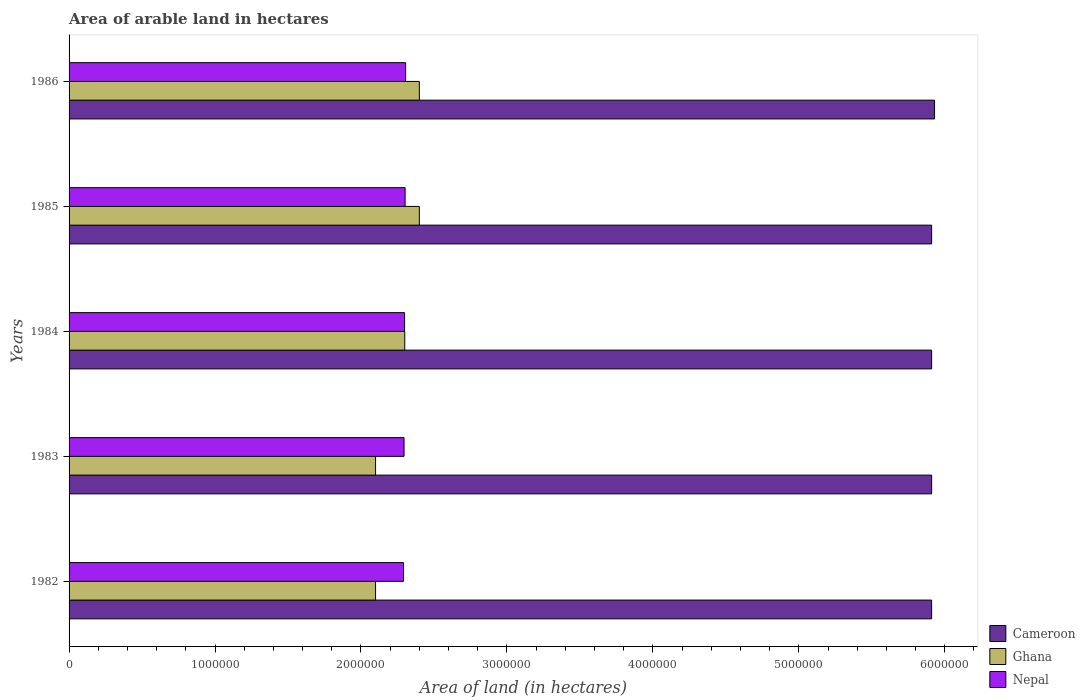Are the number of bars per tick equal to the number of legend labels?
Make the answer very short. Yes. How many bars are there on the 3rd tick from the top?
Make the answer very short. 3. How many bars are there on the 3rd tick from the bottom?
Your answer should be compact. 3. What is the label of the 5th group of bars from the top?
Ensure brevity in your answer.  1982. In how many cases, is the number of bars for a given year not equal to the number of legend labels?
Give a very brief answer. 0. What is the total arable land in Ghana in 1985?
Ensure brevity in your answer.  2.40e+06. Across all years, what is the maximum total arable land in Cameroon?
Keep it short and to the point. 5.93e+06. Across all years, what is the minimum total arable land in Ghana?
Your response must be concise. 2.10e+06. In which year was the total arable land in Ghana maximum?
Provide a short and direct response. 1985. In which year was the total arable land in Ghana minimum?
Provide a short and direct response. 1982. What is the total total arable land in Cameroon in the graph?
Your response must be concise. 2.96e+07. What is the difference between the total arable land in Nepal in 1985 and that in 1986?
Provide a short and direct response. -3600. What is the difference between the total arable land in Ghana in 1986 and the total arable land in Cameroon in 1982?
Offer a terse response. -3.51e+06. What is the average total arable land in Ghana per year?
Provide a succinct answer. 2.26e+06. In the year 1983, what is the difference between the total arable land in Nepal and total arable land in Ghana?
Give a very brief answer. 1.95e+05. What is the ratio of the total arable land in Ghana in 1984 to that in 1985?
Your response must be concise. 0.96. Is the difference between the total arable land in Nepal in 1983 and 1986 greater than the difference between the total arable land in Ghana in 1983 and 1986?
Offer a terse response. Yes. What is the difference between the highest and the lowest total arable land in Nepal?
Make the answer very short. 1.44e+04. What does the 3rd bar from the bottom in 1986 represents?
Give a very brief answer. Nepal. Is it the case that in every year, the sum of the total arable land in Nepal and total arable land in Cameroon is greater than the total arable land in Ghana?
Your answer should be compact. Yes. Does the graph contain grids?
Make the answer very short. No. How many legend labels are there?
Your answer should be very brief. 3. What is the title of the graph?
Give a very brief answer. Area of arable land in hectares. What is the label or title of the X-axis?
Make the answer very short. Area of land (in hectares). What is the label or title of the Y-axis?
Your answer should be compact. Years. What is the Area of land (in hectares) of Cameroon in 1982?
Provide a succinct answer. 5.91e+06. What is the Area of land (in hectares) of Ghana in 1982?
Your answer should be compact. 2.10e+06. What is the Area of land (in hectares) of Nepal in 1982?
Your answer should be very brief. 2.29e+06. What is the Area of land (in hectares) in Cameroon in 1983?
Give a very brief answer. 5.91e+06. What is the Area of land (in hectares) of Ghana in 1983?
Give a very brief answer. 2.10e+06. What is the Area of land (in hectares) in Nepal in 1983?
Ensure brevity in your answer.  2.30e+06. What is the Area of land (in hectares) in Cameroon in 1984?
Offer a very short reply. 5.91e+06. What is the Area of land (in hectares) in Ghana in 1984?
Your answer should be very brief. 2.30e+06. What is the Area of land (in hectares) of Nepal in 1984?
Give a very brief answer. 2.30e+06. What is the Area of land (in hectares) in Cameroon in 1985?
Offer a terse response. 5.91e+06. What is the Area of land (in hectares) of Ghana in 1985?
Give a very brief answer. 2.40e+06. What is the Area of land (in hectares) of Nepal in 1985?
Keep it short and to the point. 2.30e+06. What is the Area of land (in hectares) in Cameroon in 1986?
Keep it short and to the point. 5.93e+06. What is the Area of land (in hectares) of Ghana in 1986?
Make the answer very short. 2.40e+06. What is the Area of land (in hectares) of Nepal in 1986?
Keep it short and to the point. 2.31e+06. Across all years, what is the maximum Area of land (in hectares) of Cameroon?
Keep it short and to the point. 5.93e+06. Across all years, what is the maximum Area of land (in hectares) of Ghana?
Offer a very short reply. 2.40e+06. Across all years, what is the maximum Area of land (in hectares) in Nepal?
Offer a terse response. 2.31e+06. Across all years, what is the minimum Area of land (in hectares) of Cameroon?
Your answer should be very brief. 5.91e+06. Across all years, what is the minimum Area of land (in hectares) of Ghana?
Provide a short and direct response. 2.10e+06. Across all years, what is the minimum Area of land (in hectares) of Nepal?
Offer a terse response. 2.29e+06. What is the total Area of land (in hectares) of Cameroon in the graph?
Your answer should be very brief. 2.96e+07. What is the total Area of land (in hectares) of Ghana in the graph?
Make the answer very short. 1.13e+07. What is the total Area of land (in hectares) in Nepal in the graph?
Your answer should be compact. 1.15e+07. What is the difference between the Area of land (in hectares) in Ghana in 1982 and that in 1983?
Provide a succinct answer. 0. What is the difference between the Area of land (in hectares) of Nepal in 1982 and that in 1983?
Offer a terse response. -3600. What is the difference between the Area of land (in hectares) in Cameroon in 1982 and that in 1984?
Give a very brief answer. 0. What is the difference between the Area of land (in hectares) of Ghana in 1982 and that in 1984?
Keep it short and to the point. -2.00e+05. What is the difference between the Area of land (in hectares) of Nepal in 1982 and that in 1984?
Keep it short and to the point. -7200. What is the difference between the Area of land (in hectares) of Ghana in 1982 and that in 1985?
Ensure brevity in your answer.  -3.00e+05. What is the difference between the Area of land (in hectares) in Nepal in 1982 and that in 1985?
Ensure brevity in your answer.  -1.08e+04. What is the difference between the Area of land (in hectares) in Cameroon in 1982 and that in 1986?
Your response must be concise. -2.00e+04. What is the difference between the Area of land (in hectares) of Nepal in 1982 and that in 1986?
Keep it short and to the point. -1.44e+04. What is the difference between the Area of land (in hectares) in Cameroon in 1983 and that in 1984?
Offer a very short reply. 0. What is the difference between the Area of land (in hectares) of Nepal in 1983 and that in 1984?
Your answer should be compact. -3600. What is the difference between the Area of land (in hectares) of Cameroon in 1983 and that in 1985?
Your response must be concise. 0. What is the difference between the Area of land (in hectares) of Ghana in 1983 and that in 1985?
Your answer should be very brief. -3.00e+05. What is the difference between the Area of land (in hectares) in Nepal in 1983 and that in 1985?
Make the answer very short. -7200. What is the difference between the Area of land (in hectares) in Cameroon in 1983 and that in 1986?
Your answer should be very brief. -2.00e+04. What is the difference between the Area of land (in hectares) in Ghana in 1983 and that in 1986?
Offer a terse response. -3.00e+05. What is the difference between the Area of land (in hectares) of Nepal in 1983 and that in 1986?
Your answer should be very brief. -1.08e+04. What is the difference between the Area of land (in hectares) in Cameroon in 1984 and that in 1985?
Your answer should be very brief. 0. What is the difference between the Area of land (in hectares) in Nepal in 1984 and that in 1985?
Your response must be concise. -3600. What is the difference between the Area of land (in hectares) in Ghana in 1984 and that in 1986?
Your answer should be compact. -1.00e+05. What is the difference between the Area of land (in hectares) in Nepal in 1984 and that in 1986?
Offer a very short reply. -7200. What is the difference between the Area of land (in hectares) in Cameroon in 1985 and that in 1986?
Provide a short and direct response. -2.00e+04. What is the difference between the Area of land (in hectares) in Nepal in 1985 and that in 1986?
Make the answer very short. -3600. What is the difference between the Area of land (in hectares) of Cameroon in 1982 and the Area of land (in hectares) of Ghana in 1983?
Your response must be concise. 3.81e+06. What is the difference between the Area of land (in hectares) of Cameroon in 1982 and the Area of land (in hectares) of Nepal in 1983?
Offer a terse response. 3.61e+06. What is the difference between the Area of land (in hectares) in Ghana in 1982 and the Area of land (in hectares) in Nepal in 1983?
Give a very brief answer. -1.95e+05. What is the difference between the Area of land (in hectares) in Cameroon in 1982 and the Area of land (in hectares) in Ghana in 1984?
Your answer should be compact. 3.61e+06. What is the difference between the Area of land (in hectares) in Cameroon in 1982 and the Area of land (in hectares) in Nepal in 1984?
Provide a succinct answer. 3.61e+06. What is the difference between the Area of land (in hectares) of Ghana in 1982 and the Area of land (in hectares) of Nepal in 1984?
Provide a short and direct response. -1.99e+05. What is the difference between the Area of land (in hectares) of Cameroon in 1982 and the Area of land (in hectares) of Ghana in 1985?
Your response must be concise. 3.51e+06. What is the difference between the Area of land (in hectares) of Cameroon in 1982 and the Area of land (in hectares) of Nepal in 1985?
Your answer should be compact. 3.61e+06. What is the difference between the Area of land (in hectares) of Ghana in 1982 and the Area of land (in hectares) of Nepal in 1985?
Your response must be concise. -2.02e+05. What is the difference between the Area of land (in hectares) of Cameroon in 1982 and the Area of land (in hectares) of Ghana in 1986?
Offer a very short reply. 3.51e+06. What is the difference between the Area of land (in hectares) of Cameroon in 1982 and the Area of land (in hectares) of Nepal in 1986?
Provide a succinct answer. 3.60e+06. What is the difference between the Area of land (in hectares) of Ghana in 1982 and the Area of land (in hectares) of Nepal in 1986?
Provide a succinct answer. -2.06e+05. What is the difference between the Area of land (in hectares) in Cameroon in 1983 and the Area of land (in hectares) in Ghana in 1984?
Provide a succinct answer. 3.61e+06. What is the difference between the Area of land (in hectares) in Cameroon in 1983 and the Area of land (in hectares) in Nepal in 1984?
Keep it short and to the point. 3.61e+06. What is the difference between the Area of land (in hectares) of Ghana in 1983 and the Area of land (in hectares) of Nepal in 1984?
Ensure brevity in your answer.  -1.99e+05. What is the difference between the Area of land (in hectares) of Cameroon in 1983 and the Area of land (in hectares) of Ghana in 1985?
Offer a terse response. 3.51e+06. What is the difference between the Area of land (in hectares) of Cameroon in 1983 and the Area of land (in hectares) of Nepal in 1985?
Offer a terse response. 3.61e+06. What is the difference between the Area of land (in hectares) of Ghana in 1983 and the Area of land (in hectares) of Nepal in 1985?
Make the answer very short. -2.02e+05. What is the difference between the Area of land (in hectares) of Cameroon in 1983 and the Area of land (in hectares) of Ghana in 1986?
Offer a terse response. 3.51e+06. What is the difference between the Area of land (in hectares) in Cameroon in 1983 and the Area of land (in hectares) in Nepal in 1986?
Your answer should be very brief. 3.60e+06. What is the difference between the Area of land (in hectares) of Ghana in 1983 and the Area of land (in hectares) of Nepal in 1986?
Your answer should be very brief. -2.06e+05. What is the difference between the Area of land (in hectares) of Cameroon in 1984 and the Area of land (in hectares) of Ghana in 1985?
Ensure brevity in your answer.  3.51e+06. What is the difference between the Area of land (in hectares) of Cameroon in 1984 and the Area of land (in hectares) of Nepal in 1985?
Keep it short and to the point. 3.61e+06. What is the difference between the Area of land (in hectares) in Ghana in 1984 and the Area of land (in hectares) in Nepal in 1985?
Make the answer very short. -2400. What is the difference between the Area of land (in hectares) of Cameroon in 1984 and the Area of land (in hectares) of Ghana in 1986?
Provide a short and direct response. 3.51e+06. What is the difference between the Area of land (in hectares) in Cameroon in 1984 and the Area of land (in hectares) in Nepal in 1986?
Provide a short and direct response. 3.60e+06. What is the difference between the Area of land (in hectares) in Ghana in 1984 and the Area of land (in hectares) in Nepal in 1986?
Your response must be concise. -6000. What is the difference between the Area of land (in hectares) of Cameroon in 1985 and the Area of land (in hectares) of Ghana in 1986?
Provide a short and direct response. 3.51e+06. What is the difference between the Area of land (in hectares) of Cameroon in 1985 and the Area of land (in hectares) of Nepal in 1986?
Ensure brevity in your answer.  3.60e+06. What is the difference between the Area of land (in hectares) in Ghana in 1985 and the Area of land (in hectares) in Nepal in 1986?
Offer a very short reply. 9.40e+04. What is the average Area of land (in hectares) in Cameroon per year?
Your answer should be compact. 5.91e+06. What is the average Area of land (in hectares) of Ghana per year?
Make the answer very short. 2.26e+06. What is the average Area of land (in hectares) of Nepal per year?
Offer a very short reply. 2.30e+06. In the year 1982, what is the difference between the Area of land (in hectares) in Cameroon and Area of land (in hectares) in Ghana?
Your answer should be compact. 3.81e+06. In the year 1982, what is the difference between the Area of land (in hectares) in Cameroon and Area of land (in hectares) in Nepal?
Your answer should be compact. 3.62e+06. In the year 1982, what is the difference between the Area of land (in hectares) of Ghana and Area of land (in hectares) of Nepal?
Keep it short and to the point. -1.92e+05. In the year 1983, what is the difference between the Area of land (in hectares) of Cameroon and Area of land (in hectares) of Ghana?
Your answer should be compact. 3.81e+06. In the year 1983, what is the difference between the Area of land (in hectares) of Cameroon and Area of land (in hectares) of Nepal?
Your response must be concise. 3.61e+06. In the year 1983, what is the difference between the Area of land (in hectares) in Ghana and Area of land (in hectares) in Nepal?
Your response must be concise. -1.95e+05. In the year 1984, what is the difference between the Area of land (in hectares) of Cameroon and Area of land (in hectares) of Ghana?
Keep it short and to the point. 3.61e+06. In the year 1984, what is the difference between the Area of land (in hectares) of Cameroon and Area of land (in hectares) of Nepal?
Your answer should be compact. 3.61e+06. In the year 1984, what is the difference between the Area of land (in hectares) of Ghana and Area of land (in hectares) of Nepal?
Offer a very short reply. 1200. In the year 1985, what is the difference between the Area of land (in hectares) of Cameroon and Area of land (in hectares) of Ghana?
Your response must be concise. 3.51e+06. In the year 1985, what is the difference between the Area of land (in hectares) in Cameroon and Area of land (in hectares) in Nepal?
Give a very brief answer. 3.61e+06. In the year 1985, what is the difference between the Area of land (in hectares) in Ghana and Area of land (in hectares) in Nepal?
Offer a very short reply. 9.76e+04. In the year 1986, what is the difference between the Area of land (in hectares) in Cameroon and Area of land (in hectares) in Ghana?
Make the answer very short. 3.53e+06. In the year 1986, what is the difference between the Area of land (in hectares) in Cameroon and Area of land (in hectares) in Nepal?
Make the answer very short. 3.62e+06. In the year 1986, what is the difference between the Area of land (in hectares) in Ghana and Area of land (in hectares) in Nepal?
Your response must be concise. 9.40e+04. What is the ratio of the Area of land (in hectares) in Cameroon in 1982 to that in 1984?
Offer a very short reply. 1. What is the ratio of the Area of land (in hectares) in Cameroon in 1982 to that in 1985?
Offer a very short reply. 1. What is the ratio of the Area of land (in hectares) of Ghana in 1982 to that in 1986?
Your response must be concise. 0.88. What is the ratio of the Area of land (in hectares) of Nepal in 1982 to that in 1986?
Your response must be concise. 0.99. What is the ratio of the Area of land (in hectares) of Cameroon in 1983 to that in 1984?
Offer a very short reply. 1. What is the ratio of the Area of land (in hectares) of Nepal in 1983 to that in 1984?
Keep it short and to the point. 1. What is the ratio of the Area of land (in hectares) in Cameroon in 1983 to that in 1985?
Your answer should be very brief. 1. What is the ratio of the Area of land (in hectares) in Ghana in 1983 to that in 1985?
Give a very brief answer. 0.88. What is the ratio of the Area of land (in hectares) of Nepal in 1983 to that in 1985?
Ensure brevity in your answer.  1. What is the ratio of the Area of land (in hectares) in Ghana in 1983 to that in 1986?
Your answer should be compact. 0.88. What is the ratio of the Area of land (in hectares) of Nepal in 1984 to that in 1986?
Offer a very short reply. 1. What is the ratio of the Area of land (in hectares) in Ghana in 1985 to that in 1986?
Offer a terse response. 1. What is the ratio of the Area of land (in hectares) of Nepal in 1985 to that in 1986?
Provide a short and direct response. 1. What is the difference between the highest and the second highest Area of land (in hectares) of Ghana?
Provide a succinct answer. 0. What is the difference between the highest and the second highest Area of land (in hectares) of Nepal?
Ensure brevity in your answer.  3600. What is the difference between the highest and the lowest Area of land (in hectares) in Cameroon?
Your response must be concise. 2.00e+04. What is the difference between the highest and the lowest Area of land (in hectares) in Nepal?
Provide a succinct answer. 1.44e+04. 